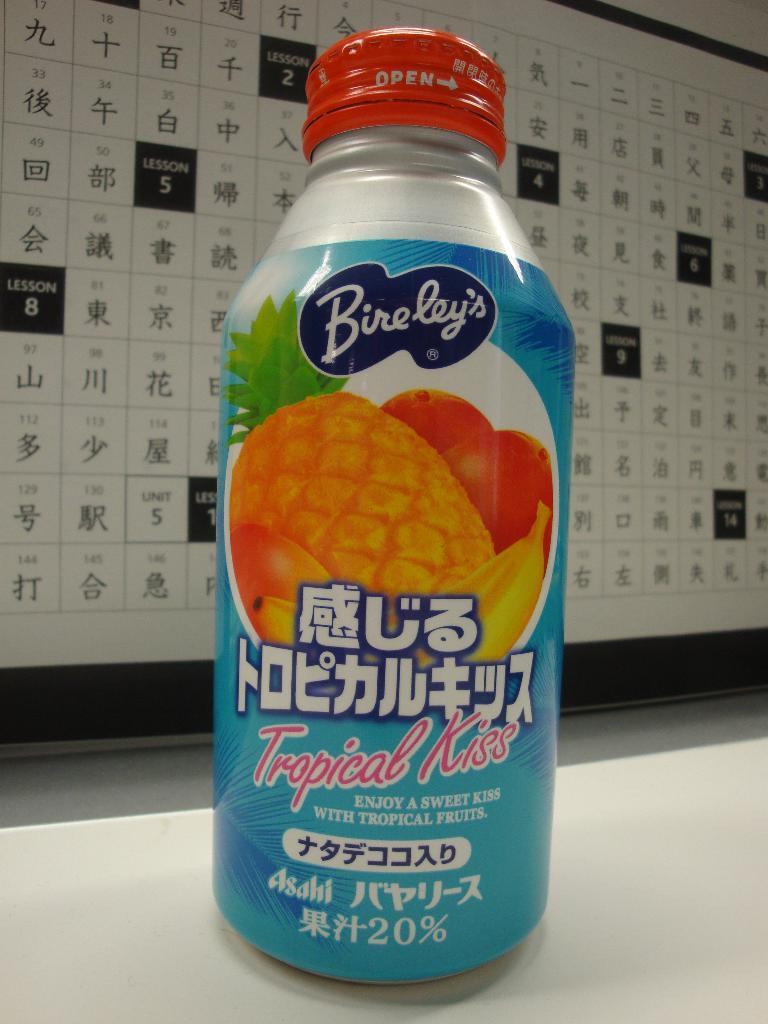<image>
Present a compact description of the photo's key features. A bottle from the company Bireley's is Tropical Kiss flavored. 